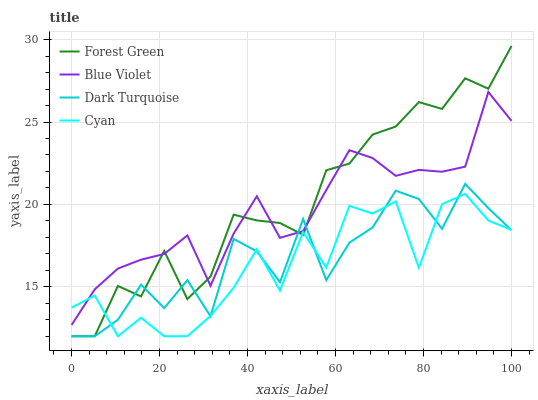Does Cyan have the minimum area under the curve?
Answer yes or no. Yes. Does Forest Green have the maximum area under the curve?
Answer yes or no. Yes. Does Blue Violet have the minimum area under the curve?
Answer yes or no. No. Does Blue Violet have the maximum area under the curve?
Answer yes or no. No. Is Blue Violet the smoothest?
Answer yes or no. Yes. Is Dark Turquoise the roughest?
Answer yes or no. Yes. Is Forest Green the smoothest?
Answer yes or no. No. Is Forest Green the roughest?
Answer yes or no. No. Does Dark Turquoise have the lowest value?
Answer yes or no. Yes. Does Blue Violet have the lowest value?
Answer yes or no. No. Does Forest Green have the highest value?
Answer yes or no. Yes. Does Blue Violet have the highest value?
Answer yes or no. No. Does Forest Green intersect Cyan?
Answer yes or no. Yes. Is Forest Green less than Cyan?
Answer yes or no. No. Is Forest Green greater than Cyan?
Answer yes or no. No. 